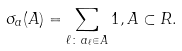Convert formula to latex. <formula><loc_0><loc_0><loc_500><loc_500>\sigma _ { a } ( A ) = \sum _ { \ell \colon \, a _ { \ell } \in A } 1 , A \subset R .</formula> 